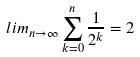<formula> <loc_0><loc_0><loc_500><loc_500>l i m _ { n \rightarrow \infty } \sum _ { k = 0 } ^ { n } \frac { 1 } { 2 ^ { k } } = 2</formula> 